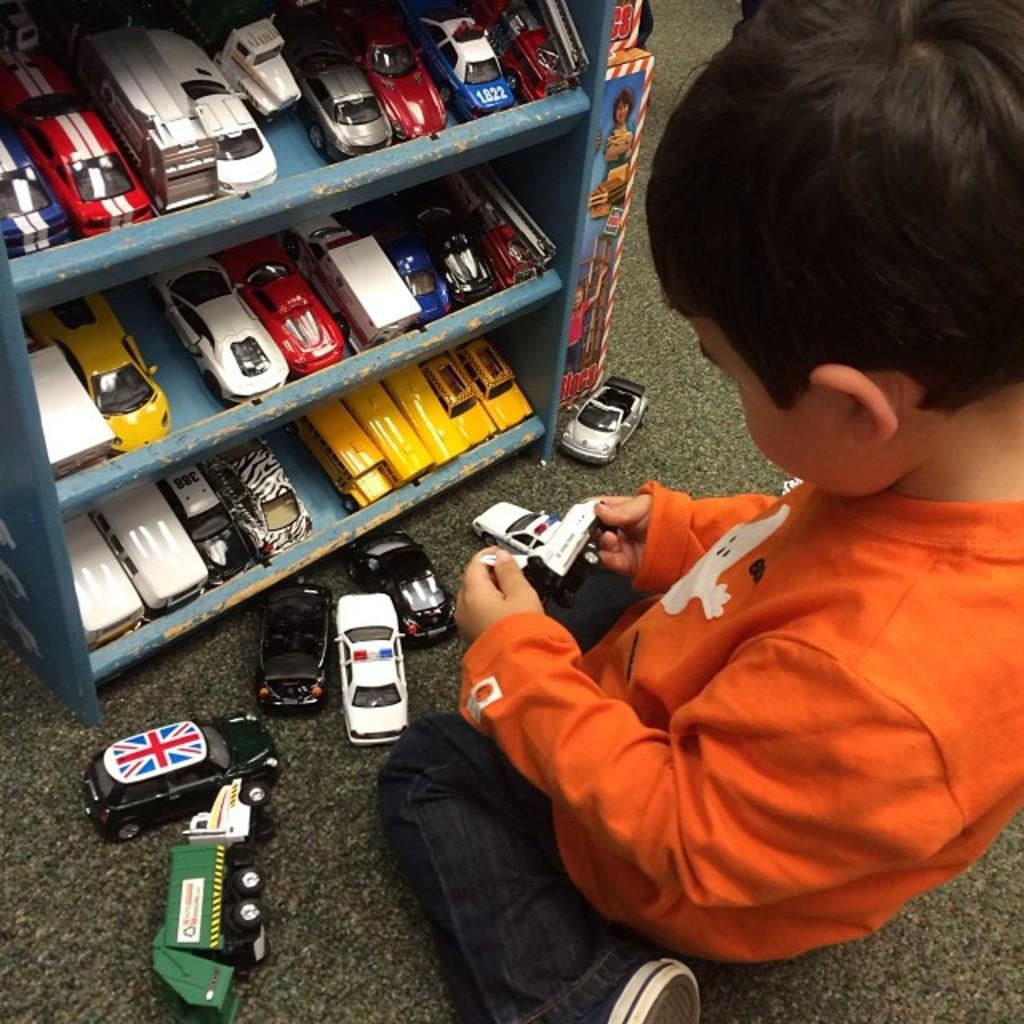Who is the main subject in the image? There is a boy in the image. What is the boy doing in the image? The boy is seated on the floor and playing with toys. Are there any other toys visible in the image? Yes, there are additional toys in front of the boy in racks. What type of amusement park can be seen in the background of the image? There is no amusement park visible in the image; it features a boy playing with toys on the floor. 